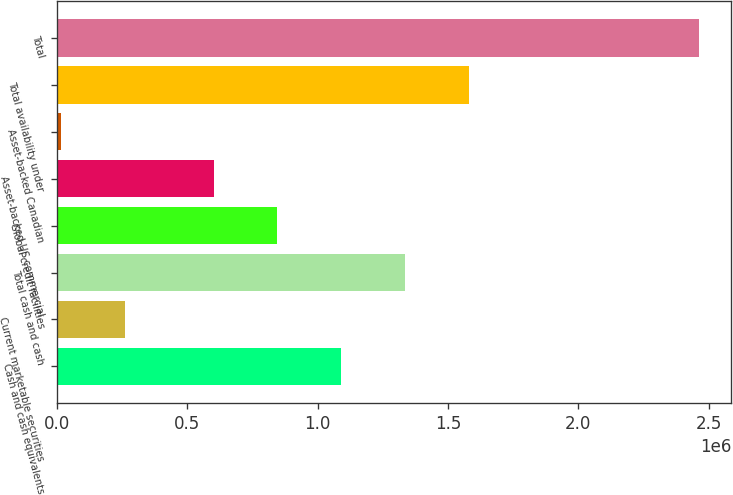<chart> <loc_0><loc_0><loc_500><loc_500><bar_chart><fcel>Cash and cash equivalents<fcel>Current marketable securities<fcel>Total cash and cash<fcel>Global credit facilities<fcel>Asset-backed US commercial<fcel>Asset-backed Canadian<fcel>Total availability under<fcel>Total<nl><fcel>1.08986e+06<fcel>258649<fcel>1.33479e+06<fcel>844930<fcel>600000<fcel>13719<fcel>1.57972e+06<fcel>2.46302e+06<nl></chart> 